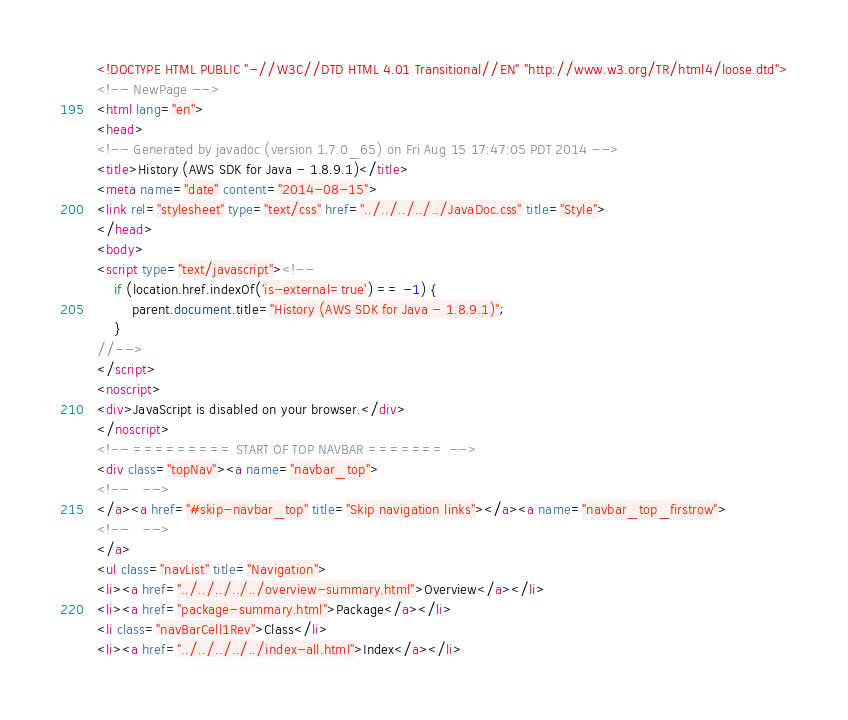<code> <loc_0><loc_0><loc_500><loc_500><_HTML_><!DOCTYPE HTML PUBLIC "-//W3C//DTD HTML 4.01 Transitional//EN" "http://www.w3.org/TR/html4/loose.dtd">
<!-- NewPage -->
<html lang="en">
<head>
<!-- Generated by javadoc (version 1.7.0_65) on Fri Aug 15 17:47:05 PDT 2014 -->
<title>History (AWS SDK for Java - 1.8.9.1)</title>
<meta name="date" content="2014-08-15">
<link rel="stylesheet" type="text/css" href="../../../../../JavaDoc.css" title="Style">
</head>
<body>
<script type="text/javascript"><!--
    if (location.href.indexOf('is-external=true') == -1) {
        parent.document.title="History (AWS SDK for Java - 1.8.9.1)";
    }
//-->
</script>
<noscript>
<div>JavaScript is disabled on your browser.</div>
</noscript>
<!-- ========= START OF TOP NAVBAR ======= -->
<div class="topNav"><a name="navbar_top">
<!--   -->
</a><a href="#skip-navbar_top" title="Skip navigation links"></a><a name="navbar_top_firstrow">
<!--   -->
</a>
<ul class="navList" title="Navigation">
<li><a href="../../../../../overview-summary.html">Overview</a></li>
<li><a href="package-summary.html">Package</a></li>
<li class="navBarCell1Rev">Class</li>
<li><a href="../../../../../index-all.html">Index</a></li></code> 